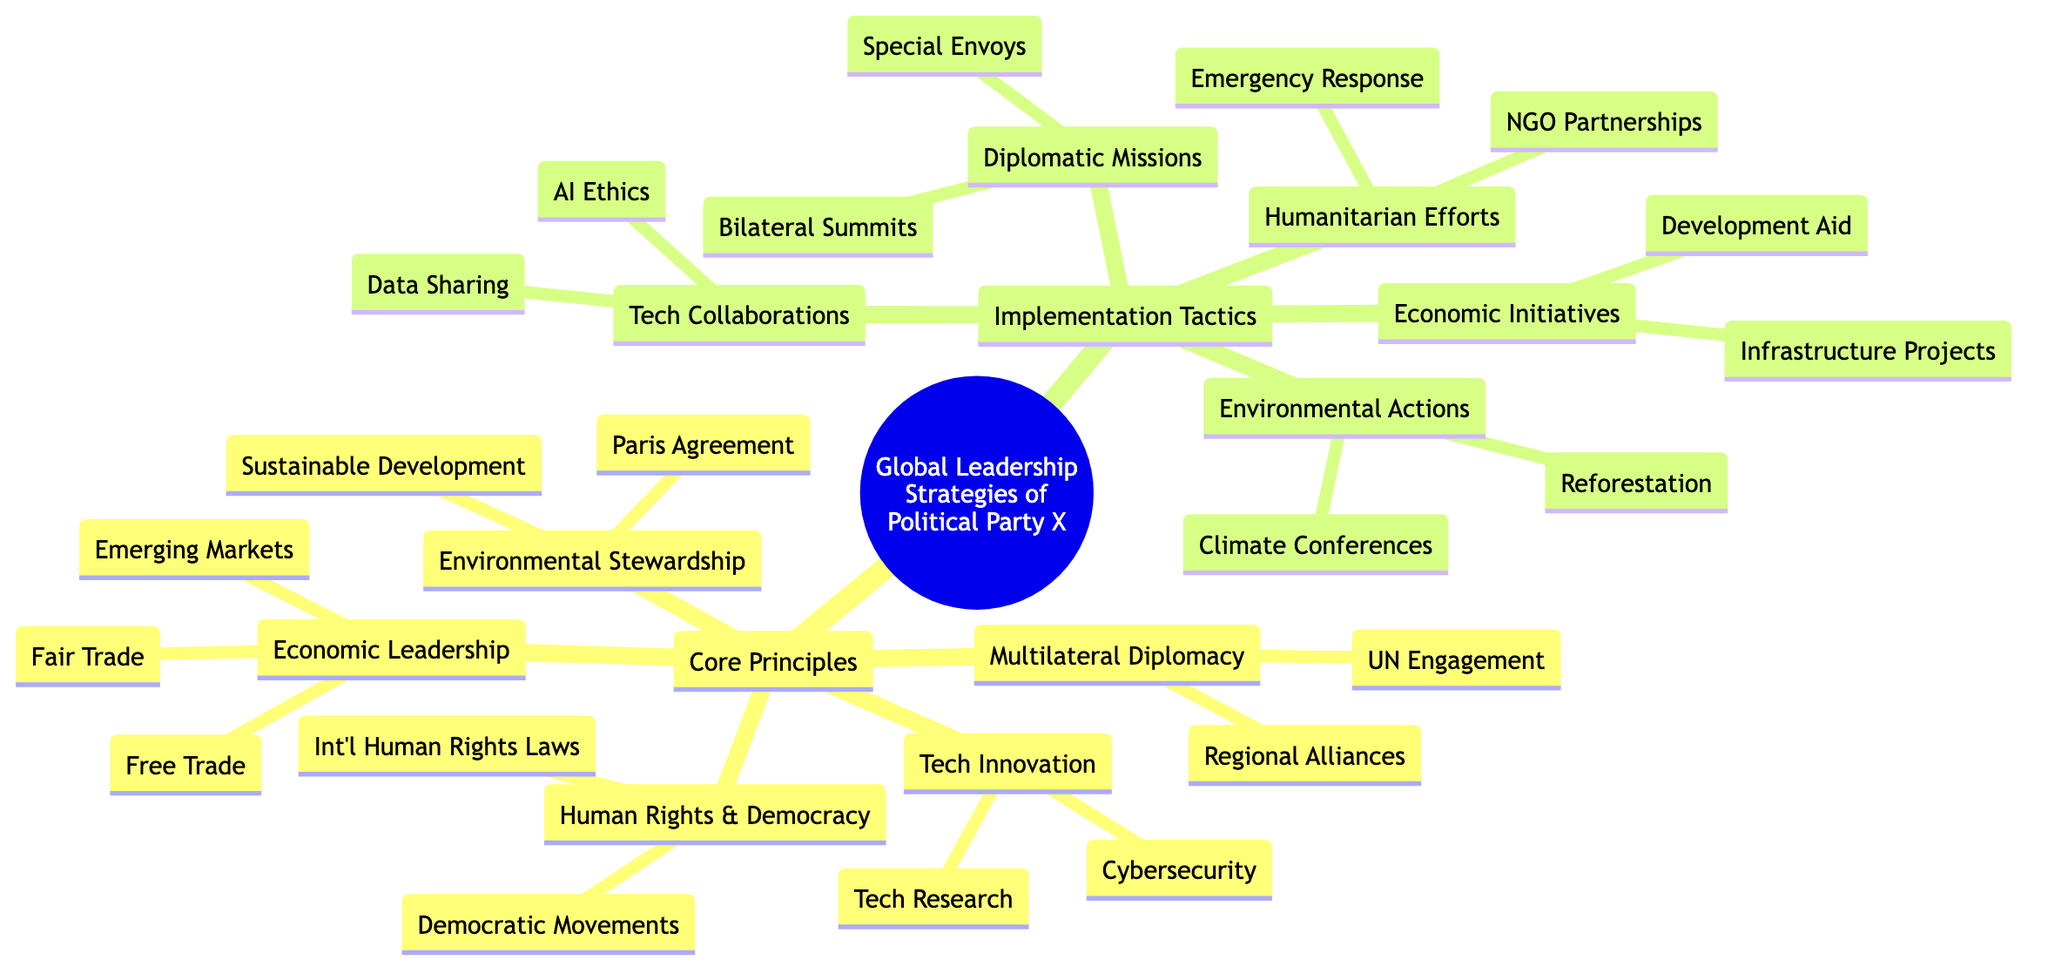What are the core principles of Global Leadership Strategies? The diagram lists five core principles under "Global Leadership Strategies": Multilateral Diplomacy, Economic Leadership, Human Rights and Democracy, Environmental Stewardship, and Technological Innovation.
Answer: Five How many implementation tactics are listed in the diagram? The diagram lists five distinct implementation tactics: Diplomatic Missions, Economic Initiatives, Humanitarian Efforts, Environmental Actions, and Tech Collaborations.
Answer: Five What is one of the components of Economic Leadership? One of the components under Economic Leadership is "Support for Free Trade Agreements." This is a specific tactic mentioned in the mind map under that principle.
Answer: Support for Free Trade Agreements Which core principle includes commitments to the Paris Agreement? The principle that includes commitments to the Paris Agreement is Environmental Stewardship. It is specifically mentioned as part of that core principle in the diagram.
Answer: Environmental Stewardship What type of effort is represented by "Emergency Response Task Forces"? "Emergency Response Task Forces" is categorized under Humanitarian Efforts as one of the tactics mentioned in the diagram.
Answer: Humanitarian Efforts How are "Special Envoys for Conflict Regions" related to Global Leadership Strategies? "Special Envoys for Conflict Regions" falls under the category of Diplomatic Missions, which is one of the implementation tactics used in Global Leadership Strategies.
Answer: Diplomatic Missions Which two principles emphasize international collaboration? The two principles that emphasize international collaboration are Multilateral Diplomacy and Technological Innovation, as both focus on partnerships and global engagement.
Answer: Multilateral Diplomacy and Technological Innovation In total, how many components are there under the principle of Human Rights and Democracy? There are two components listed under Human Rights and Democracy: Support for Democratic Movements and Advocacy for International Human Rights Laws.
Answer: Two 